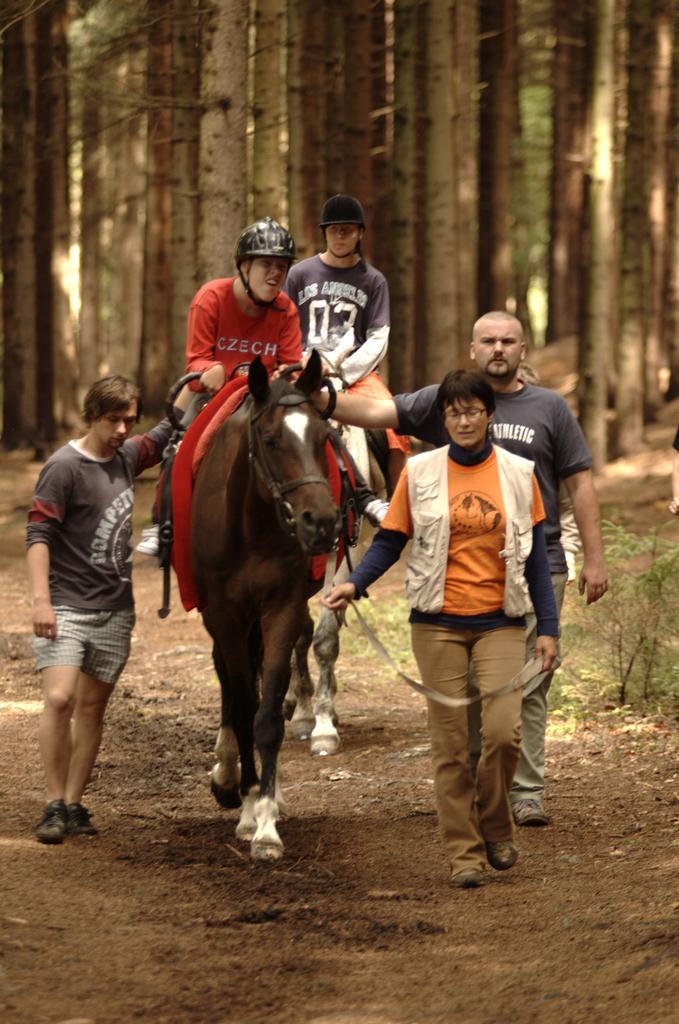Can you describe this image briefly? In this picture we can see few people walking with the horse. And there are two persons sitting on the horse. They wear helmet. And on the background there are trees. 